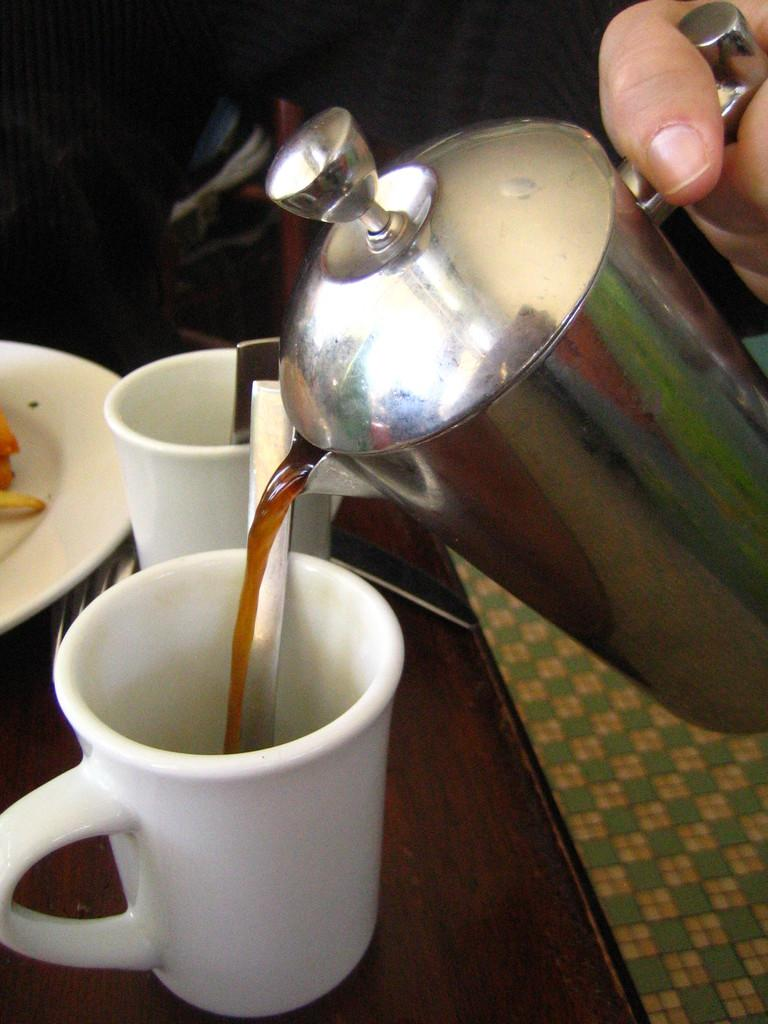What is the main object in the image? There is a teapot in the image. How many cups are visible in the image? There are two cups in the image. Where are the cups located? The cups are on a table. What is the person in the image doing? The person is pouring a drink into one of the cups. How many tomatoes are on the table in the image? There is no mention of tomatoes in the image; the focus is on the teapot, cups, and the person pouring a drink. 